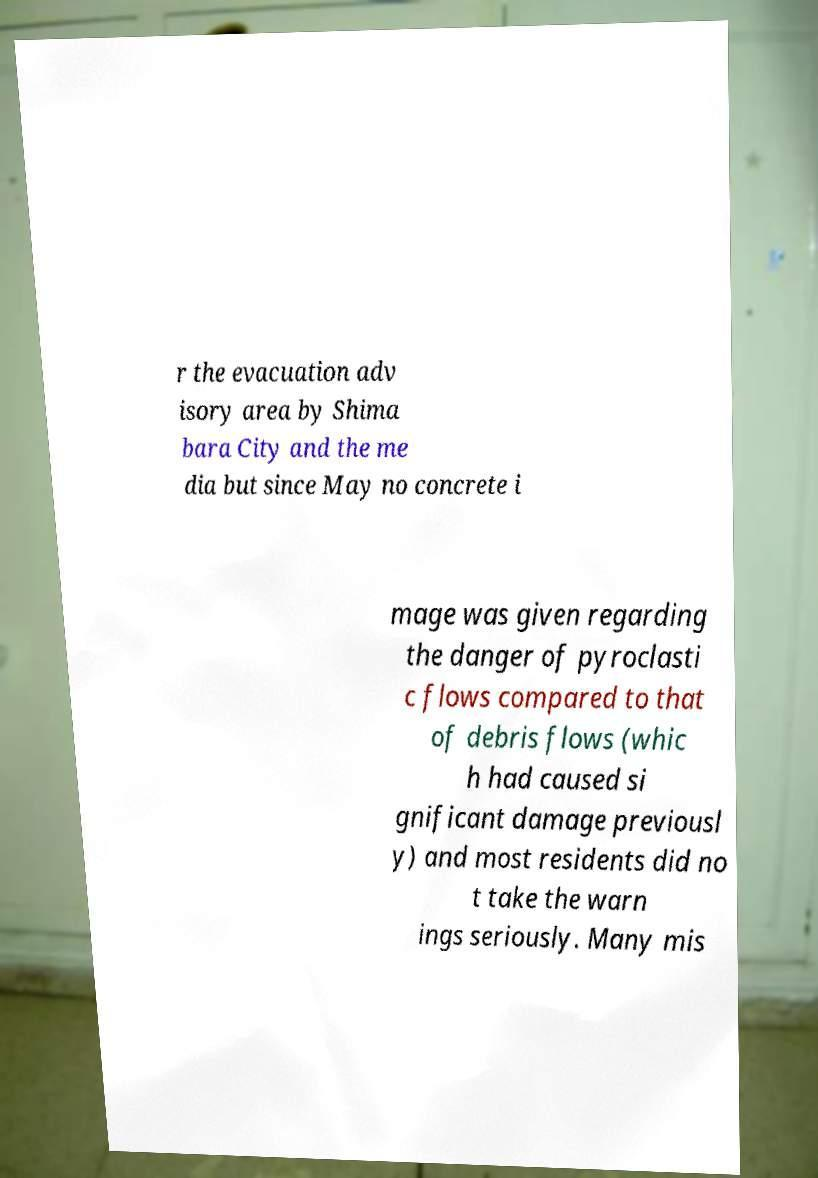Could you assist in decoding the text presented in this image and type it out clearly? r the evacuation adv isory area by Shima bara City and the me dia but since May no concrete i mage was given regarding the danger of pyroclasti c flows compared to that of debris flows (whic h had caused si gnificant damage previousl y) and most residents did no t take the warn ings seriously. Many mis 